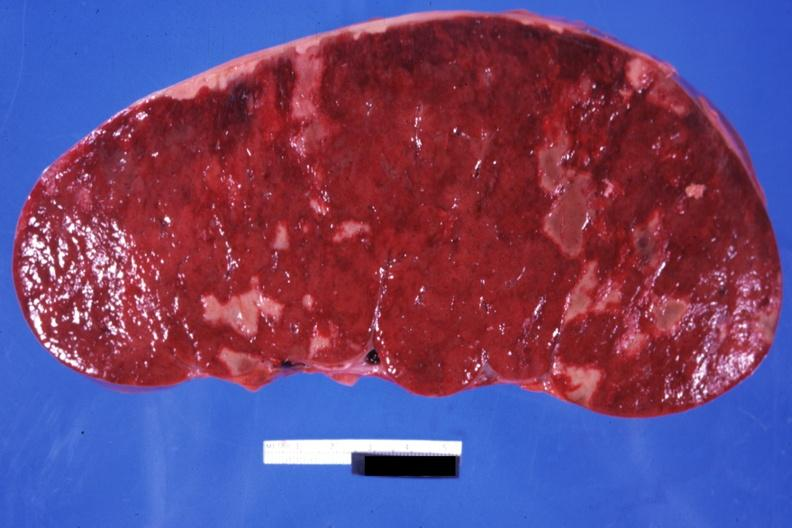s chest and abdomen slide present?
Answer the question using a single word or phrase. No 